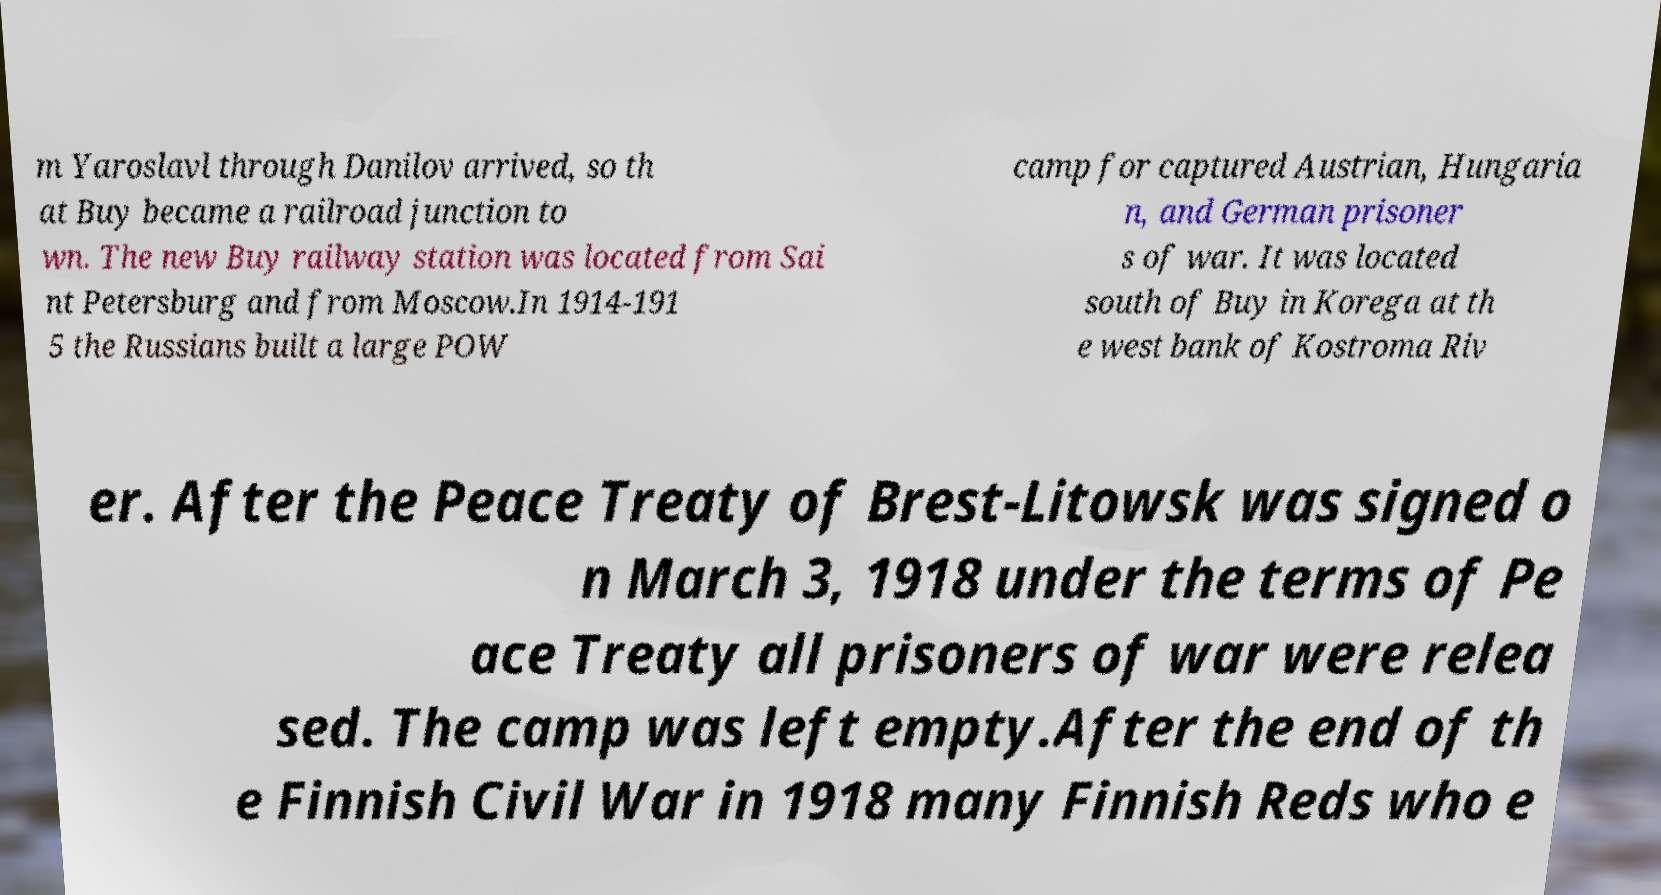Please read and relay the text visible in this image. What does it say? m Yaroslavl through Danilov arrived, so th at Buy became a railroad junction to wn. The new Buy railway station was located from Sai nt Petersburg and from Moscow.In 1914-191 5 the Russians built a large POW camp for captured Austrian, Hungaria n, and German prisoner s of war. It was located south of Buy in Korega at th e west bank of Kostroma Riv er. After the Peace Treaty of Brest-Litowsk was signed o n March 3, 1918 under the terms of Pe ace Treaty all prisoners of war were relea sed. The camp was left empty.After the end of th e Finnish Civil War in 1918 many Finnish Reds who e 